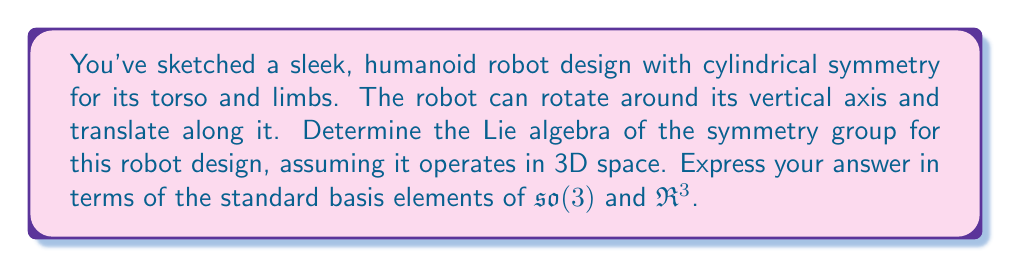Can you solve this math problem? To determine the Lie algebra of the symmetry group for this robot design, we need to consider the continuous symmetries of the robot:

1. Rotational symmetry around the vertical axis:
   This corresponds to rotations around the z-axis, which is represented by the generator $L_z$ in $\mathfrak{so}(3)$.

2. Translational symmetry along the vertical axis:
   This corresponds to translations along the z-axis, which is represented by the generator $T_z$ in $\mathfrak{R}^3$.

The Lie algebra of the symmetry group is the linear span of these generators. 

In the standard basis of $\mathfrak{so}(3)$, $L_z$ is represented as:

$$L_z = \begin{pmatrix}
0 & -1 & 0 \\
1 & 0 & 0 \\
0 & 0 & 0
\end{pmatrix}$$

The translation generator $T_z$ can be represented as a vector in $\mathfrak{R}^3$:

$$T_z = \begin{pmatrix}
0 \\
0 \\
1
\end{pmatrix}$$

The Lie algebra of the symmetry group is then the direct sum of the one-dimensional subspace of $\mathfrak{so}(3)$ spanned by $L_z$ and the one-dimensional subspace of $\mathfrak{R}^3$ spanned by $T_z$.

This Lie algebra corresponds to the group $SO(2) \times \mathbb{R}$, which represents rotations around the z-axis and translations along the z-axis.
Answer: The Lie algebra of the symmetry group is $\mathfrak{g} = \text{span}\{L_z, T_z\} \cong \mathfrak{so}(2) \oplus \mathfrak{R}$, where $L_z$ is the generator of rotations around the z-axis in $\mathfrak{so}(3)$ and $T_z$ is the generator of translations along the z-axis in $\mathfrak{R}^3$. 